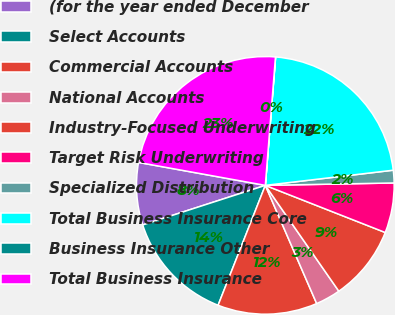Convert chart to OTSL. <chart><loc_0><loc_0><loc_500><loc_500><pie_chart><fcel>(for the year ended December<fcel>Select Accounts<fcel>Commercial Accounts<fcel>National Accounts<fcel>Industry-Focused Underwriting<fcel>Target Risk Underwriting<fcel>Specialized Distribution<fcel>Total Business Insurance Core<fcel>Business Insurance Other<fcel>Total Business Insurance<nl><fcel>7.82%<fcel>14.06%<fcel>12.5%<fcel>3.14%<fcel>9.38%<fcel>6.26%<fcel>1.58%<fcel>21.85%<fcel>0.02%<fcel>23.41%<nl></chart> 